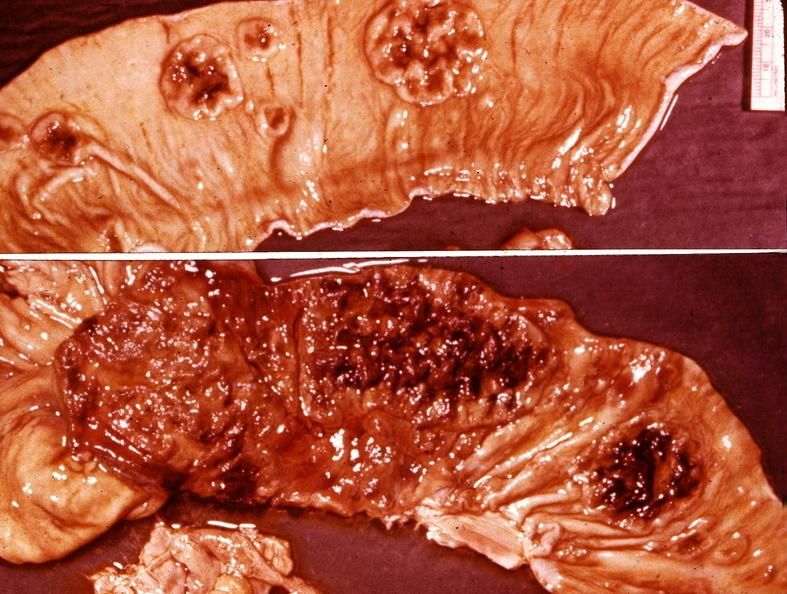s gastrointestinal present?
Answer the question using a single word or phrase. Yes 